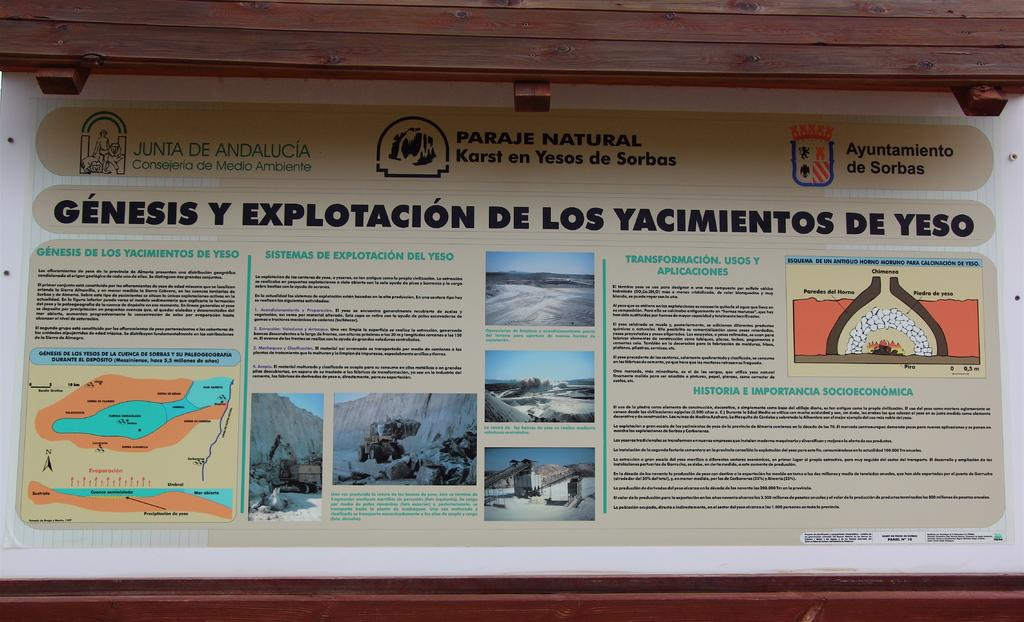<image>
Relay a brief, clear account of the picture shown. A wall with a poster board that says Genesis Y Explotacion de Los Yacimients de Yeso 